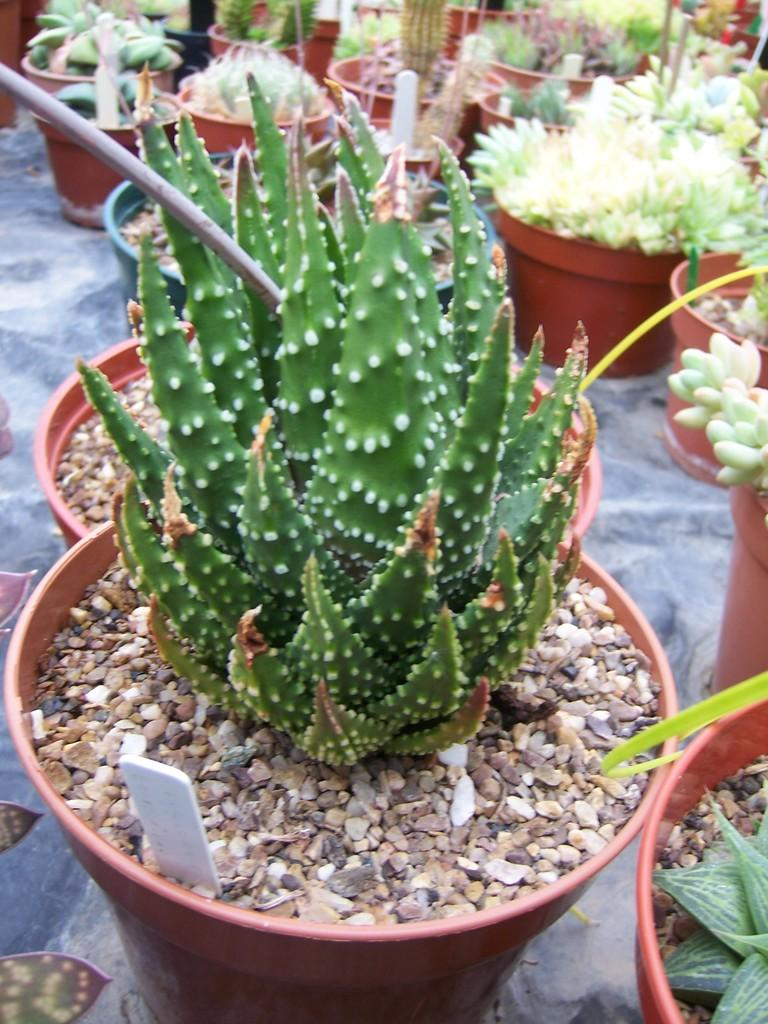What type of objects are in the image that contain plants? There are pots with plants in the image. Can you identify any specific type of plant in the image? Yes, one of the plants is a cactus. What is unique about the pot that contains the cactus? The cactus is in a pot with stones. Where are the pots with plants located in the image? The pots are kept on the floor. What type of clover can be seen growing on the roof in the image? There is no clover or roof present in the image; it features pots with plants on the floor. 